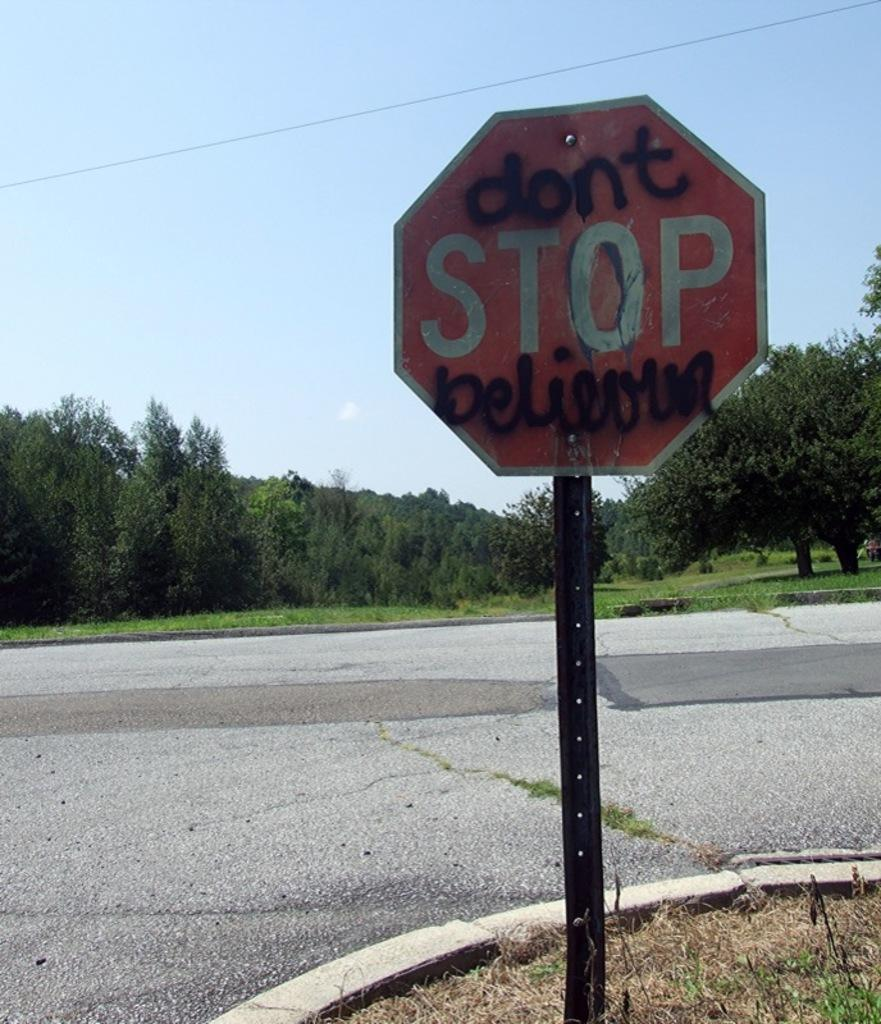Provide a one-sentence caption for the provided image. A stop sign at a street corner with "don't" and "believun" added in back spray paint. 